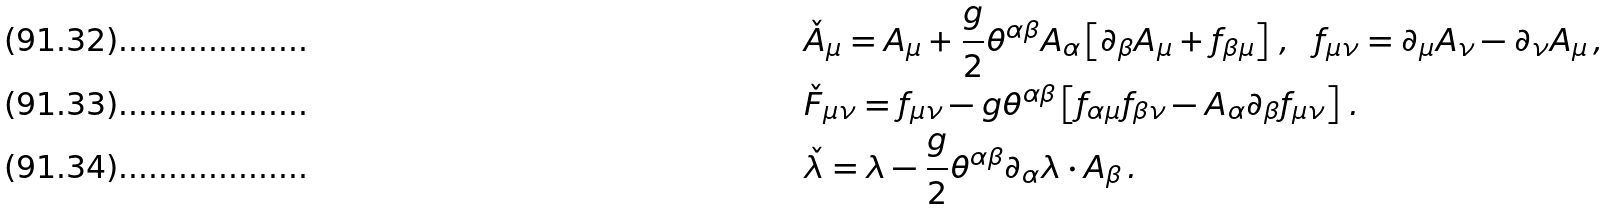<formula> <loc_0><loc_0><loc_500><loc_500>& \check { A } _ { \mu } = A _ { \mu } + \frac { g } { 2 } \theta ^ { \alpha \beta } A _ { \alpha } \left [ \partial _ { \beta } A _ { \mu } + f _ { \beta \mu } \right ] \, , \ \ f _ { \mu \nu } = \partial _ { \mu } A _ { \nu } - \partial _ { \nu } A _ { \mu } \, , \\ & \check { F } _ { \mu \nu } = f _ { \mu \nu } - g \theta ^ { \alpha \beta } \left [ f _ { \alpha \mu } f _ { \beta \nu } - A _ { \alpha } \partial _ { \beta } f _ { \mu \nu } \right ] \, . \\ & \check { \lambda } = \lambda - \frac { g } { 2 } \theta ^ { \alpha \beta } \partial _ { \alpha } \lambda \cdot A _ { \beta } \, .</formula> 